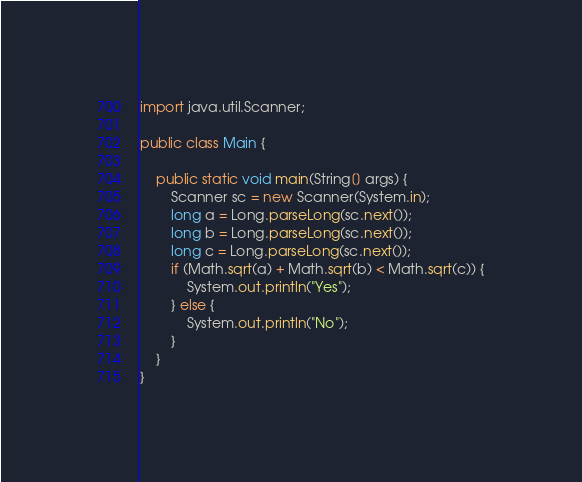Convert code to text. <code><loc_0><loc_0><loc_500><loc_500><_Java_>import java.util.Scanner;

public class Main {

    public static void main(String[] args) {
        Scanner sc = new Scanner(System.in);
        long a = Long.parseLong(sc.next());
        long b = Long.parseLong(sc.next());
        long c = Long.parseLong(sc.next());
        if (Math.sqrt(a) + Math.sqrt(b) < Math.sqrt(c)) {
            System.out.println("Yes");
        } else {
            System.out.println("No");
        }
    }
}</code> 